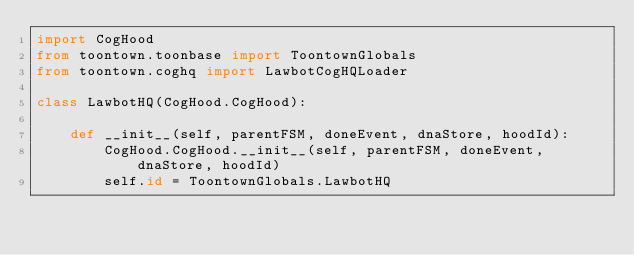Convert code to text. <code><loc_0><loc_0><loc_500><loc_500><_Python_>import CogHood
from toontown.toonbase import ToontownGlobals
from toontown.coghq import LawbotCogHQLoader

class LawbotHQ(CogHood.CogHood):

    def __init__(self, parentFSM, doneEvent, dnaStore, hoodId):
        CogHood.CogHood.__init__(self, parentFSM, doneEvent, dnaStore, hoodId)
        self.id = ToontownGlobals.LawbotHQ</code> 